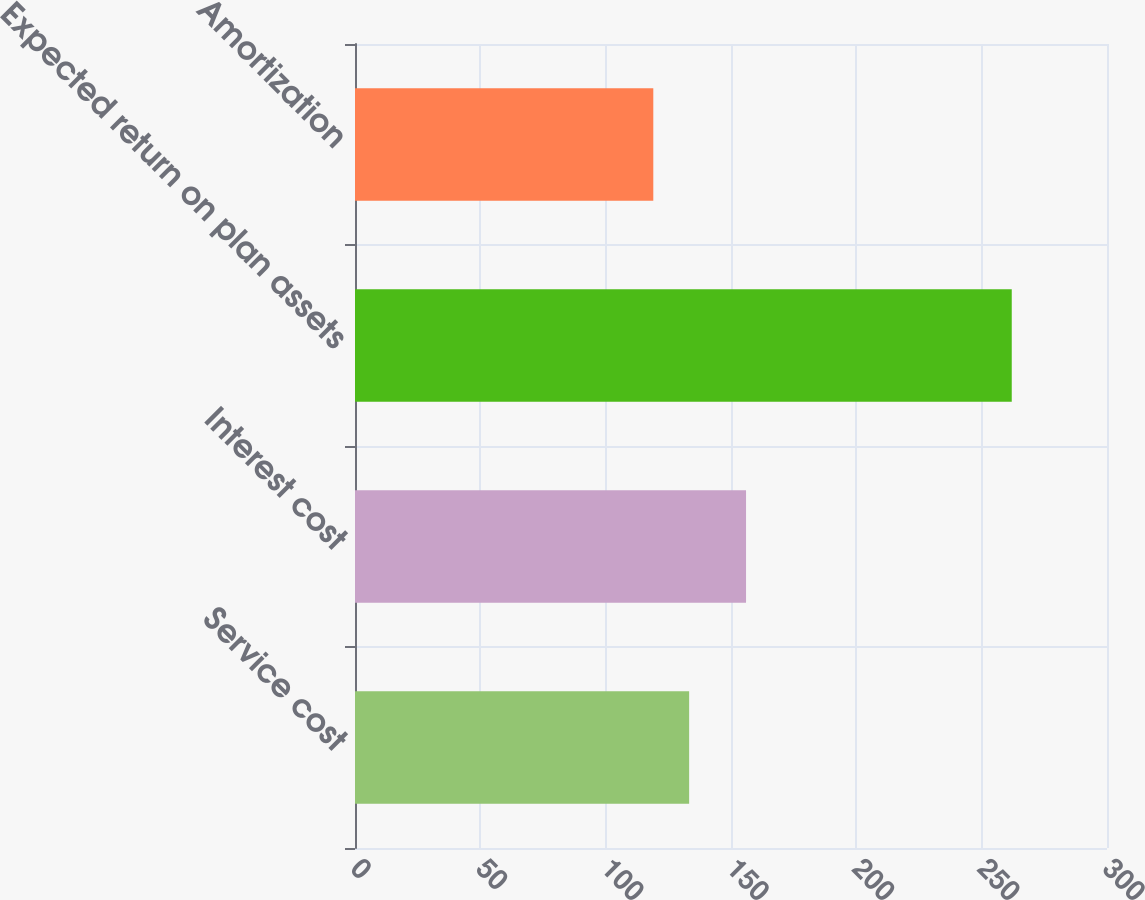<chart> <loc_0><loc_0><loc_500><loc_500><bar_chart><fcel>Service cost<fcel>Interest cost<fcel>Expected return on plan assets<fcel>Amortization<nl><fcel>133.3<fcel>156<fcel>262<fcel>119<nl></chart> 